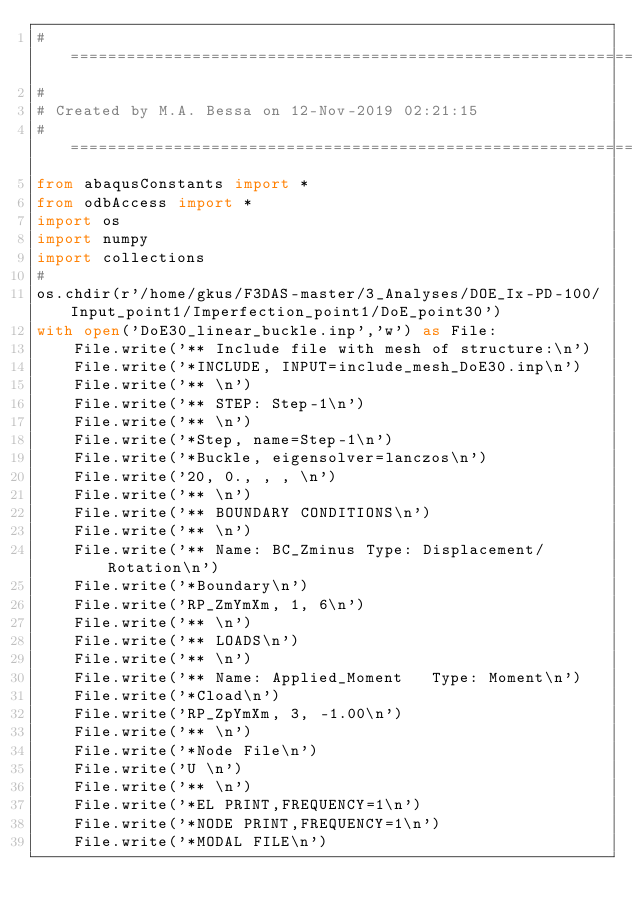Convert code to text. <code><loc_0><loc_0><loc_500><loc_500><_Python_>#=====================================================================#
#
# Created by M.A. Bessa on 12-Nov-2019 02:21:15
#=====================================================================#
from abaqusConstants import *
from odbAccess import *
import os
import numpy
import collections
#
os.chdir(r'/home/gkus/F3DAS-master/3_Analyses/DOE_Ix-PD-100/Input_point1/Imperfection_point1/DoE_point30')
with open('DoE30_linear_buckle.inp','w') as File:
    File.write('** Include file with mesh of structure:\n')
    File.write('*INCLUDE, INPUT=include_mesh_DoE30.inp\n')
    File.write('** \n')
    File.write('** STEP: Step-1\n')
    File.write('** \n')
    File.write('*Step, name=Step-1\n')
    File.write('*Buckle, eigensolver=lanczos\n')
    File.write('20, 0., , , \n')
    File.write('** \n')
    File.write('** BOUNDARY CONDITIONS\n')
    File.write('** \n')
    File.write('** Name: BC_Zminus Type: Displacement/Rotation\n')
    File.write('*Boundary\n')
    File.write('RP_ZmYmXm, 1, 6\n')
    File.write('** \n')
    File.write('** LOADS\n')
    File.write('** \n')
    File.write('** Name: Applied_Moment   Type: Moment\n')
    File.write('*Cload\n')
    File.write('RP_ZpYmXm, 3, -1.00\n')
    File.write('** \n')
    File.write('*Node File\n')
    File.write('U \n')
    File.write('** \n')
    File.write('*EL PRINT,FREQUENCY=1\n')
    File.write('*NODE PRINT,FREQUENCY=1\n')
    File.write('*MODAL FILE\n')</code> 